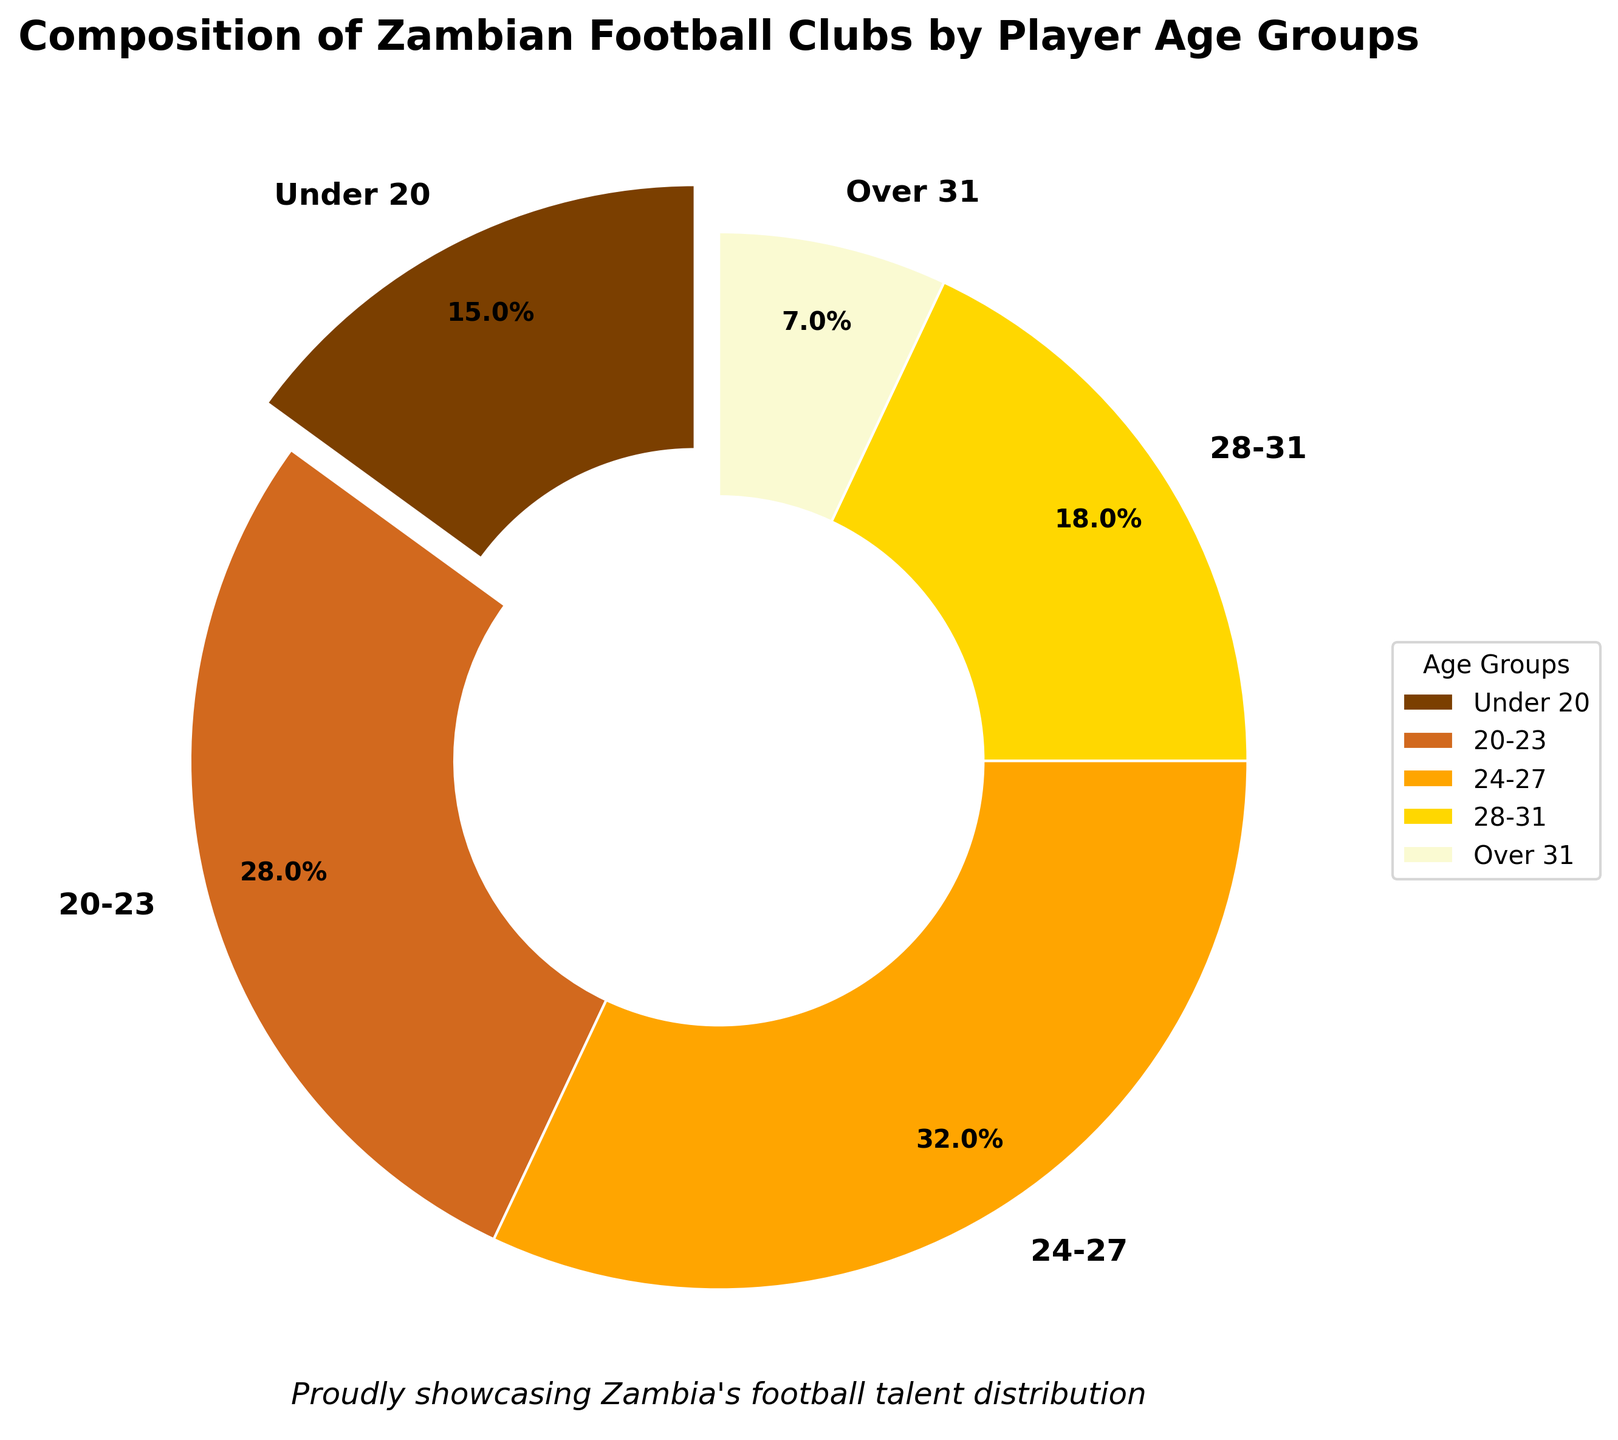Which age group has the largest percentage of players in Zambian football clubs? By observing the pie chart, the slice representing the age group with the largest percentage can be identified. The 24-27 age group has the largest slice, indicating it has the largest percentage.
Answer: 24-27 What is the combined percentage of players aged under 20 and over 31? Add the percentage values for the Under 20 group (15%) and the Over 31 group (7%). 15% + 7% equals 22%.
Answer: 22% Which two age groups have a combined percentage closest to 50%? By adding the percentages of different combinations of age groups, the closest pair to 50% can be found. The 20-23 group (28%) and 24-27 group (32%) together make 60%, while the 24-27 group (32%) and 28-31 group (18%) make 50%, which is the closest.
Answer: 24-27 and 28-31 How does the percentage of the 20-23 age group compare to that of the Over 31 age group? Compare the percentage of the 20-23 age group (28%) with the Over 31 age group (7%). The 20-23 group has a higher percentage.
Answer: 20-23 is higher Which age group is represented by the color orange in the chart? Identify the color orange used in the pie chart and match it to the corresponding age group listed in the legend. Orange corresponds to the 24-27 age group.
Answer: 24-27 By how much does the percentage of players in the 28-31 age group exceed those in the Over 31 age group? Subtract the percentage of the Over 31 group (7%) from the 28-31 group (18%) to find the difference. 18% - 7% equals 11%.
Answer: 11% What is the percentage representation of players aged between 20 and 31 in total? Add the percentages of the age groups within the 20-31 range: 20-23 (28%), 24-27 (32%), and 28-31 (18%). 28% + 32% + 18% equals 78%.
Answer: 78% Of the age groups under 20 and 20-23, which one has a smaller percentage of players? Compare the percentages of the Under 20 age group (15%) and the 20-23 age group (28%). The Under 20 group has a smaller percentage.
Answer: Under 20 What is the color of the slice representing players aged over 31 in the pie chart? Identify the color associated with the Over 31 age group by looking at the pie chart and the legend. The color is light yellow.
Answer: Light yellow What fraction of players are in the 24-27 age group? Convert the percentage of players in the 24-27 age group (32%) to a fraction. Since 32 out of 100 can be simplified to 8 out of 25, the fraction is 8/25.
Answer: 8/25 